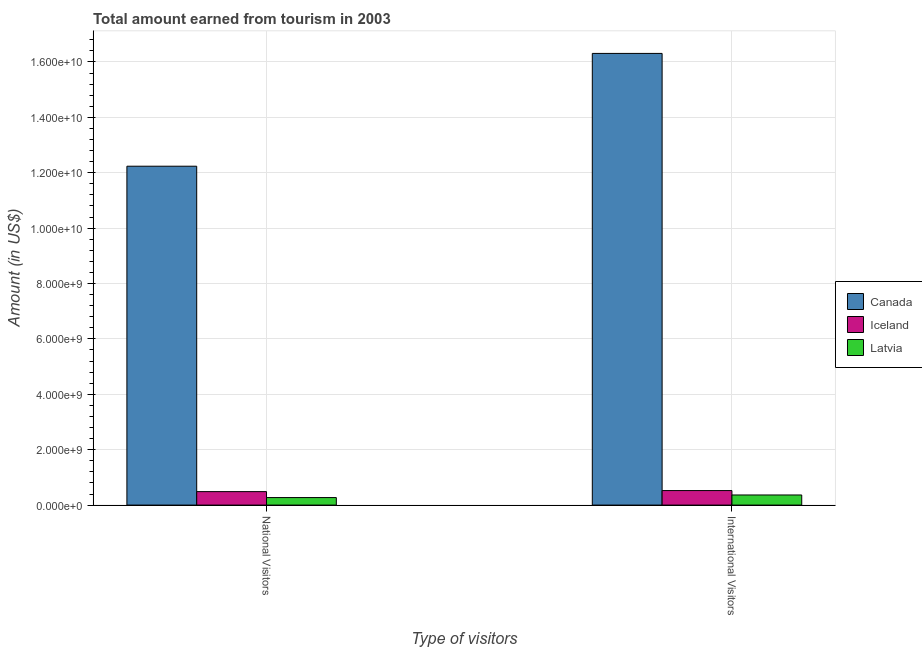How many different coloured bars are there?
Give a very brief answer. 3. Are the number of bars per tick equal to the number of legend labels?
Offer a terse response. Yes. How many bars are there on the 1st tick from the right?
Offer a terse response. 3. What is the label of the 1st group of bars from the left?
Make the answer very short. National Visitors. What is the amount earned from international visitors in Canada?
Provide a succinct answer. 1.63e+1. Across all countries, what is the maximum amount earned from international visitors?
Provide a short and direct response. 1.63e+1. Across all countries, what is the minimum amount earned from national visitors?
Keep it short and to the point. 2.71e+08. In which country was the amount earned from national visitors maximum?
Ensure brevity in your answer.  Canada. In which country was the amount earned from international visitors minimum?
Your answer should be very brief. Latvia. What is the total amount earned from national visitors in the graph?
Keep it short and to the point. 1.30e+1. What is the difference between the amount earned from national visitors in Iceland and that in Latvia?
Your answer should be compact. 2.15e+08. What is the difference between the amount earned from international visitors in Latvia and the amount earned from national visitors in Iceland?
Make the answer very short. -1.21e+08. What is the average amount earned from national visitors per country?
Make the answer very short. 4.33e+09. What is the difference between the amount earned from international visitors and amount earned from national visitors in Latvia?
Offer a very short reply. 9.40e+07. What is the ratio of the amount earned from international visitors in Canada to that in Latvia?
Ensure brevity in your answer.  44.68. What does the 3rd bar from the left in National Visitors represents?
Give a very brief answer. Latvia. What does the 3rd bar from the right in International Visitors represents?
Keep it short and to the point. Canada. Are all the bars in the graph horizontal?
Your answer should be very brief. No. What is the difference between two consecutive major ticks on the Y-axis?
Your answer should be compact. 2.00e+09. Are the values on the major ticks of Y-axis written in scientific E-notation?
Provide a short and direct response. Yes. How are the legend labels stacked?
Ensure brevity in your answer.  Vertical. What is the title of the graph?
Provide a short and direct response. Total amount earned from tourism in 2003. What is the label or title of the X-axis?
Offer a terse response. Type of visitors. What is the Amount (in US$) in Canada in National Visitors?
Your answer should be very brief. 1.22e+1. What is the Amount (in US$) in Iceland in National Visitors?
Make the answer very short. 4.86e+08. What is the Amount (in US$) of Latvia in National Visitors?
Your answer should be compact. 2.71e+08. What is the Amount (in US$) of Canada in International Visitors?
Ensure brevity in your answer.  1.63e+1. What is the Amount (in US$) in Iceland in International Visitors?
Your answer should be compact. 5.24e+08. What is the Amount (in US$) of Latvia in International Visitors?
Offer a terse response. 3.65e+08. Across all Type of visitors, what is the maximum Amount (in US$) in Canada?
Offer a terse response. 1.63e+1. Across all Type of visitors, what is the maximum Amount (in US$) in Iceland?
Ensure brevity in your answer.  5.24e+08. Across all Type of visitors, what is the maximum Amount (in US$) of Latvia?
Give a very brief answer. 3.65e+08. Across all Type of visitors, what is the minimum Amount (in US$) of Canada?
Provide a short and direct response. 1.22e+1. Across all Type of visitors, what is the minimum Amount (in US$) in Iceland?
Offer a very short reply. 4.86e+08. Across all Type of visitors, what is the minimum Amount (in US$) of Latvia?
Your answer should be compact. 2.71e+08. What is the total Amount (in US$) of Canada in the graph?
Your answer should be compact. 2.85e+1. What is the total Amount (in US$) in Iceland in the graph?
Give a very brief answer. 1.01e+09. What is the total Amount (in US$) of Latvia in the graph?
Your response must be concise. 6.36e+08. What is the difference between the Amount (in US$) in Canada in National Visitors and that in International Visitors?
Your answer should be compact. -4.07e+09. What is the difference between the Amount (in US$) in Iceland in National Visitors and that in International Visitors?
Provide a short and direct response. -3.80e+07. What is the difference between the Amount (in US$) in Latvia in National Visitors and that in International Visitors?
Provide a succinct answer. -9.40e+07. What is the difference between the Amount (in US$) of Canada in National Visitors and the Amount (in US$) of Iceland in International Visitors?
Offer a very short reply. 1.17e+1. What is the difference between the Amount (in US$) in Canada in National Visitors and the Amount (in US$) in Latvia in International Visitors?
Provide a succinct answer. 1.19e+1. What is the difference between the Amount (in US$) in Iceland in National Visitors and the Amount (in US$) in Latvia in International Visitors?
Your response must be concise. 1.21e+08. What is the average Amount (in US$) of Canada per Type of visitors?
Offer a terse response. 1.43e+1. What is the average Amount (in US$) in Iceland per Type of visitors?
Make the answer very short. 5.05e+08. What is the average Amount (in US$) of Latvia per Type of visitors?
Give a very brief answer. 3.18e+08. What is the difference between the Amount (in US$) in Canada and Amount (in US$) in Iceland in National Visitors?
Offer a very short reply. 1.18e+1. What is the difference between the Amount (in US$) in Canada and Amount (in US$) in Latvia in National Visitors?
Provide a short and direct response. 1.20e+1. What is the difference between the Amount (in US$) of Iceland and Amount (in US$) of Latvia in National Visitors?
Offer a terse response. 2.15e+08. What is the difference between the Amount (in US$) of Canada and Amount (in US$) of Iceland in International Visitors?
Your answer should be very brief. 1.58e+1. What is the difference between the Amount (in US$) of Canada and Amount (in US$) of Latvia in International Visitors?
Your answer should be compact. 1.59e+1. What is the difference between the Amount (in US$) of Iceland and Amount (in US$) of Latvia in International Visitors?
Make the answer very short. 1.59e+08. What is the ratio of the Amount (in US$) in Canada in National Visitors to that in International Visitors?
Keep it short and to the point. 0.75. What is the ratio of the Amount (in US$) of Iceland in National Visitors to that in International Visitors?
Offer a very short reply. 0.93. What is the ratio of the Amount (in US$) of Latvia in National Visitors to that in International Visitors?
Offer a terse response. 0.74. What is the difference between the highest and the second highest Amount (in US$) of Canada?
Your answer should be very brief. 4.07e+09. What is the difference between the highest and the second highest Amount (in US$) in Iceland?
Provide a succinct answer. 3.80e+07. What is the difference between the highest and the second highest Amount (in US$) in Latvia?
Provide a succinct answer. 9.40e+07. What is the difference between the highest and the lowest Amount (in US$) in Canada?
Your answer should be very brief. 4.07e+09. What is the difference between the highest and the lowest Amount (in US$) of Iceland?
Offer a terse response. 3.80e+07. What is the difference between the highest and the lowest Amount (in US$) of Latvia?
Offer a very short reply. 9.40e+07. 